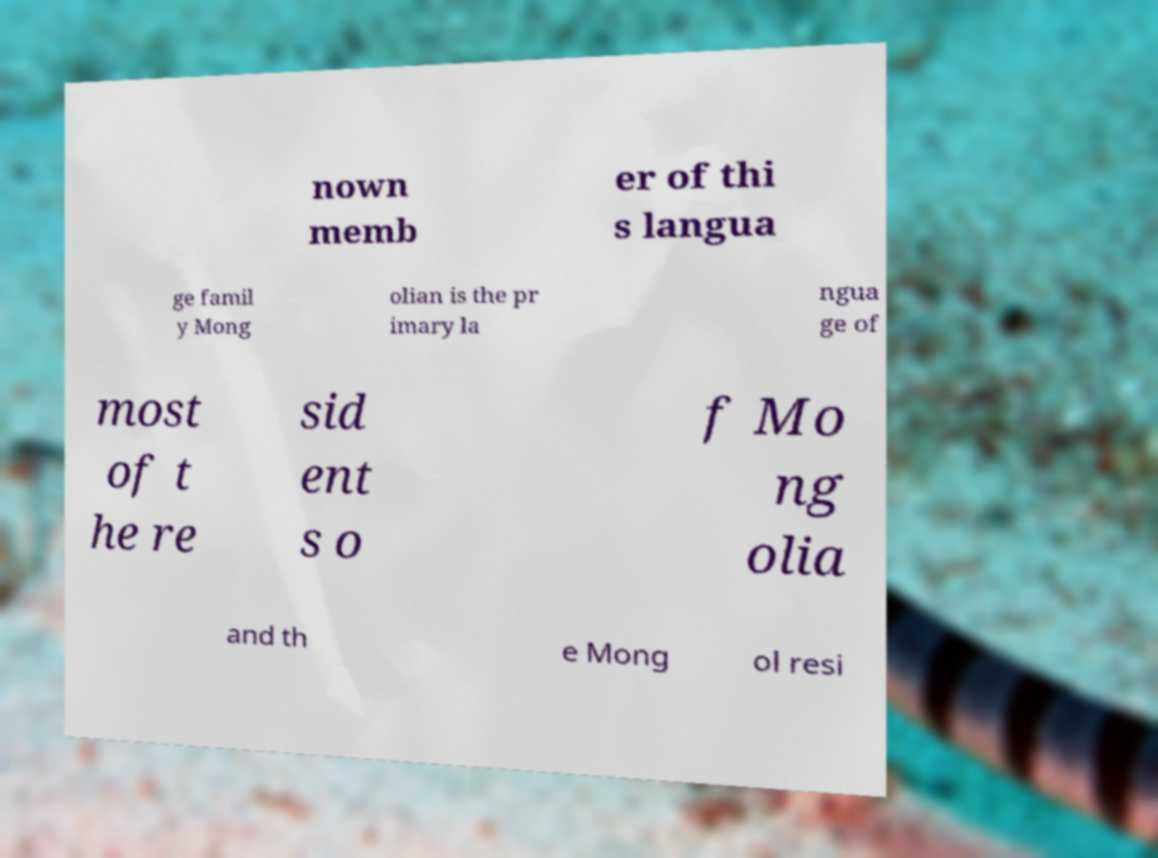Could you assist in decoding the text presented in this image and type it out clearly? nown memb er of thi s langua ge famil y Mong olian is the pr imary la ngua ge of most of t he re sid ent s o f Mo ng olia and th e Mong ol resi 